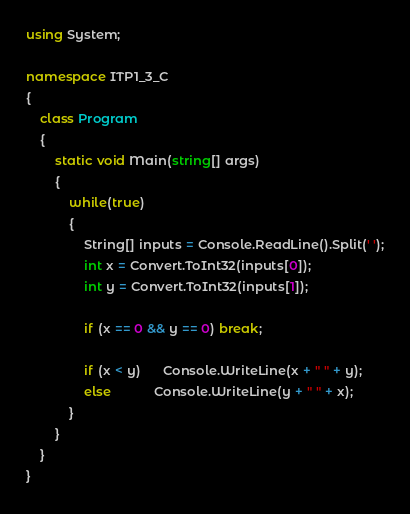Convert code to text. <code><loc_0><loc_0><loc_500><loc_500><_C#_>using System;

namespace ITP1_3_C
{
    class Program
    {
        static void Main(string[] args)
        {
            while(true)
            {
                String[] inputs = Console.ReadLine().Split(' ');
                int x = Convert.ToInt32(inputs[0]);
                int y = Convert.ToInt32(inputs[1]);

                if (x == 0 && y == 0) break;

                if (x < y)      Console.WriteLine(x + " " + y);
                else            Console.WriteLine(y + " " + x);
            }
        }
    }
}</code> 